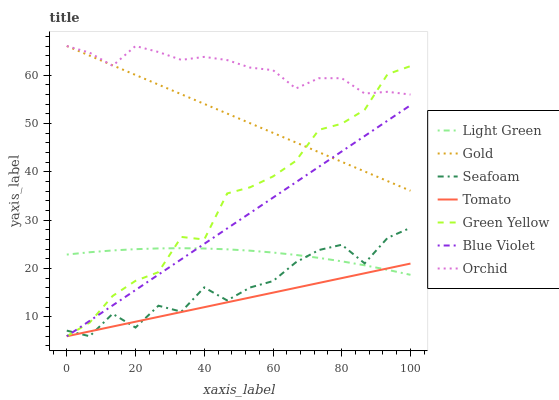Does Tomato have the minimum area under the curve?
Answer yes or no. Yes. Does Orchid have the maximum area under the curve?
Answer yes or no. Yes. Does Gold have the minimum area under the curve?
Answer yes or no. No. Does Gold have the maximum area under the curve?
Answer yes or no. No. Is Tomato the smoothest?
Answer yes or no. Yes. Is Seafoam the roughest?
Answer yes or no. Yes. Is Gold the smoothest?
Answer yes or no. No. Is Gold the roughest?
Answer yes or no. No. Does Tomato have the lowest value?
Answer yes or no. Yes. Does Gold have the lowest value?
Answer yes or no. No. Does Orchid have the highest value?
Answer yes or no. Yes. Does Seafoam have the highest value?
Answer yes or no. No. Is Light Green less than Orchid?
Answer yes or no. Yes. Is Orchid greater than Tomato?
Answer yes or no. Yes. Does Seafoam intersect Light Green?
Answer yes or no. Yes. Is Seafoam less than Light Green?
Answer yes or no. No. Is Seafoam greater than Light Green?
Answer yes or no. No. Does Light Green intersect Orchid?
Answer yes or no. No. 